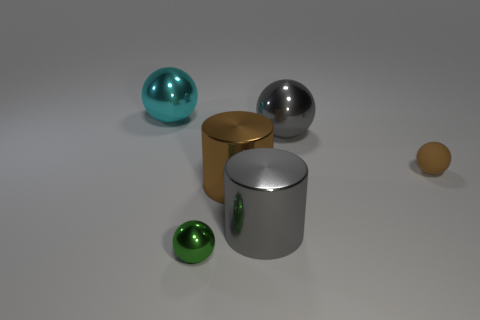Subtract all big gray shiny balls. How many balls are left? 3 Subtract 2 cylinders. How many cylinders are left? 0 Subtract all green spheres. Subtract all red cubes. How many spheres are left? 3 Subtract all gray balls. How many brown cylinders are left? 1 Subtract all large shiny spheres. Subtract all big cyan metallic objects. How many objects are left? 3 Add 2 big things. How many big things are left? 6 Add 1 small green metallic objects. How many small green metallic objects exist? 2 Add 3 large things. How many objects exist? 9 Subtract all green spheres. How many spheres are left? 3 Subtract 0 blue balls. How many objects are left? 6 